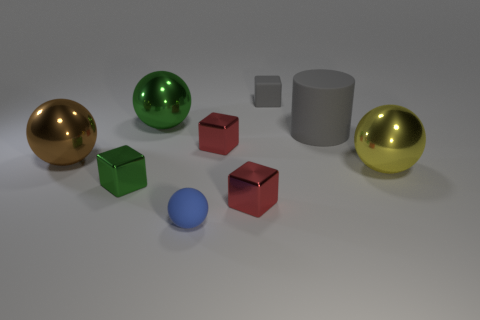Subtract 1 blocks. How many blocks are left? 3 Subtract all gray spheres. Subtract all purple blocks. How many spheres are left? 4 Add 1 blue matte spheres. How many objects exist? 10 Subtract all cylinders. How many objects are left? 8 Add 9 small gray rubber blocks. How many small gray rubber blocks exist? 10 Subtract 1 green balls. How many objects are left? 8 Subtract all blue balls. Subtract all tiny red shiny cubes. How many objects are left? 6 Add 4 small gray matte blocks. How many small gray matte blocks are left? 5 